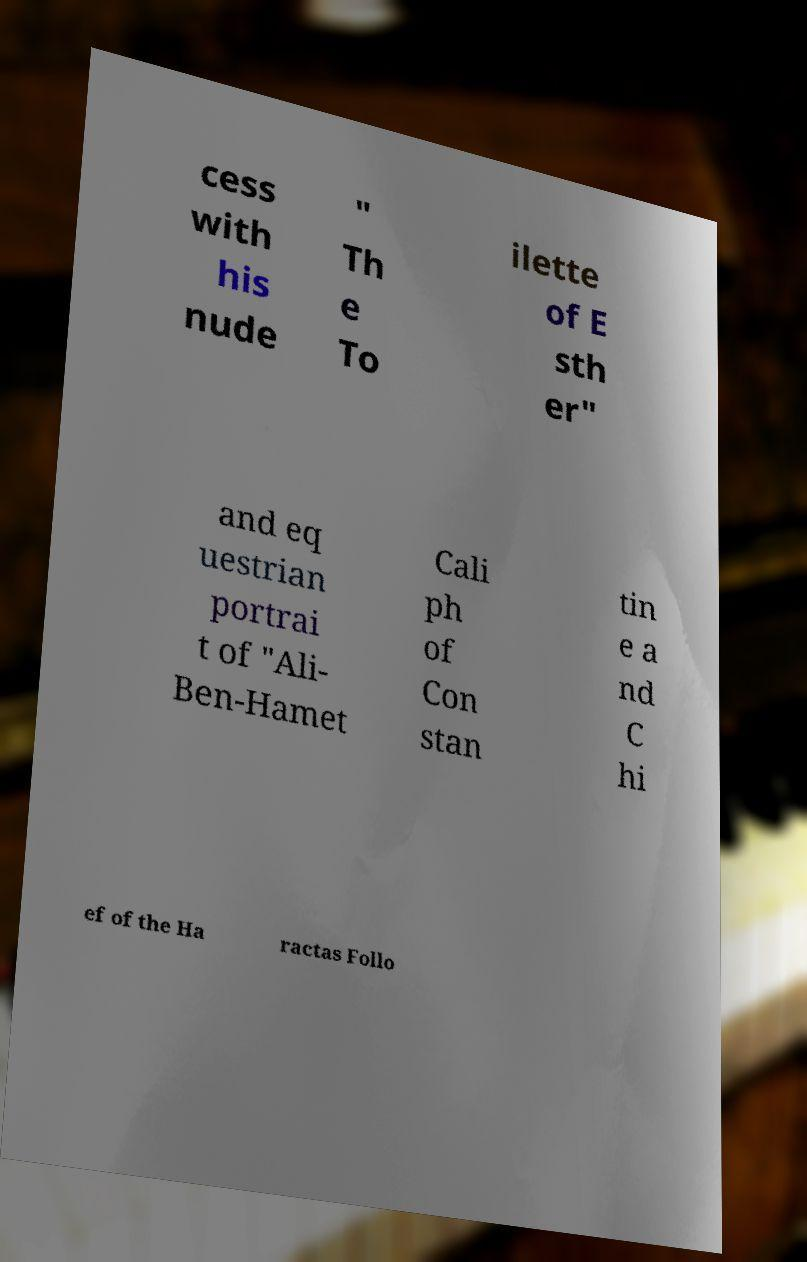Can you read and provide the text displayed in the image?This photo seems to have some interesting text. Can you extract and type it out for me? cess with his nude " Th e To ilette of E sth er" and eq uestrian portrai t of "Ali- Ben-Hamet Cali ph of Con stan tin e a nd C hi ef of the Ha ractas Follo 